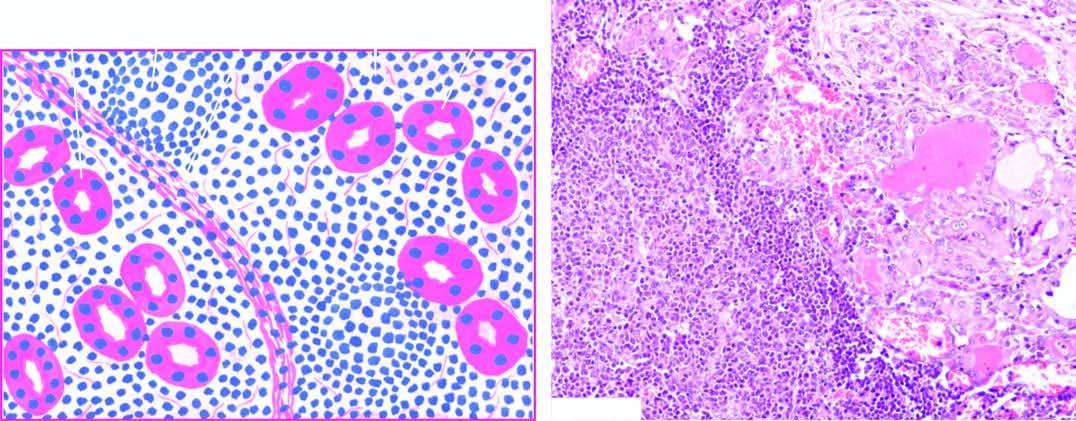what do histologic features include infiltration with?
Answer the question using a single word or phrase. Formation of lymphoid follicles 